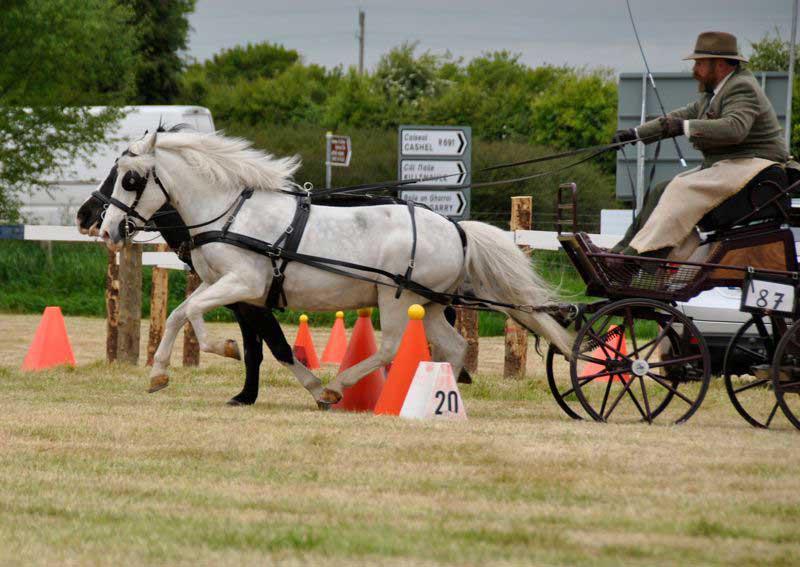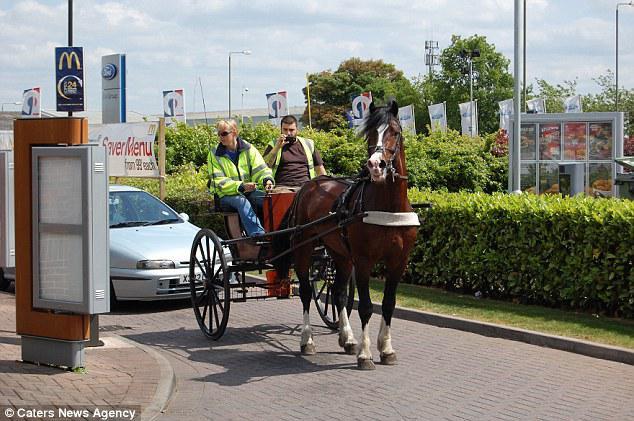The first image is the image on the left, the second image is the image on the right. Analyze the images presented: Is the assertion "An image shows a type of cart with no horse attached." valid? Answer yes or no. No. The first image is the image on the left, the second image is the image on the right. Considering the images on both sides, is "In 1 of the images, 1 carriage has no horse pulling it." valid? Answer yes or no. No. 